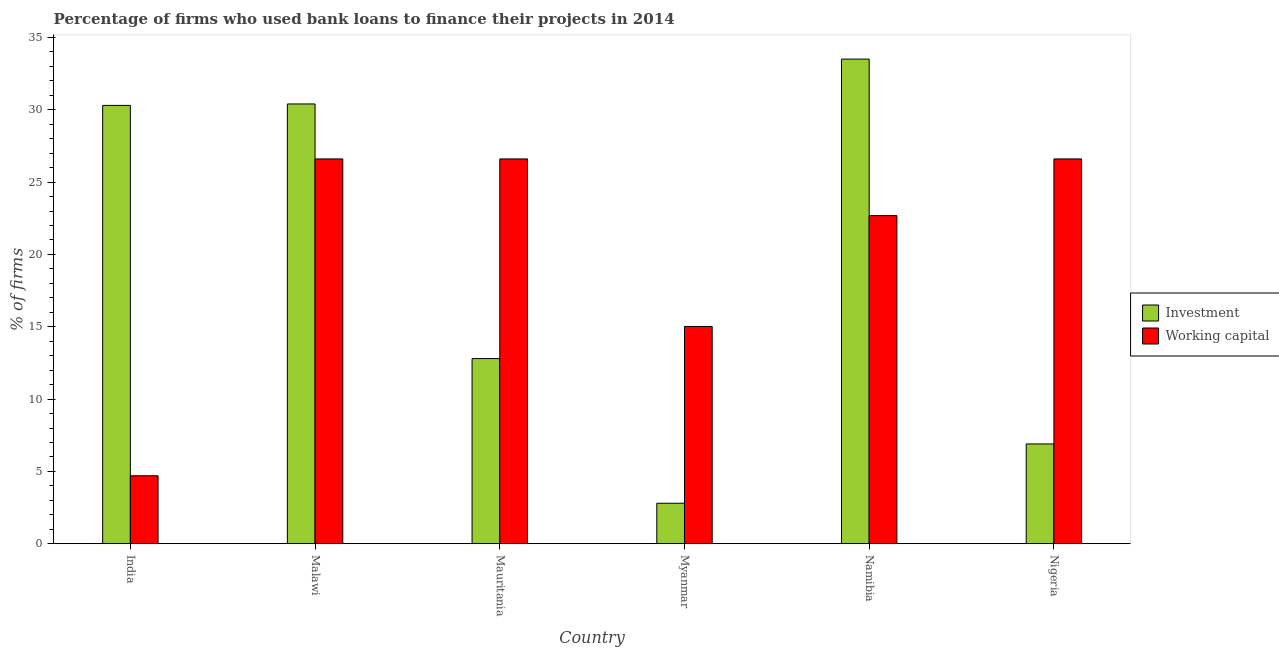How many groups of bars are there?
Give a very brief answer. 6. Are the number of bars on each tick of the X-axis equal?
Your response must be concise. Yes. How many bars are there on the 4th tick from the right?
Provide a succinct answer. 2. What is the label of the 3rd group of bars from the left?
Offer a very short reply. Mauritania. What is the percentage of firms using banks to finance working capital in Malawi?
Give a very brief answer. 26.6. Across all countries, what is the maximum percentage of firms using banks to finance investment?
Provide a succinct answer. 33.5. In which country was the percentage of firms using banks to finance investment maximum?
Ensure brevity in your answer.  Namibia. In which country was the percentage of firms using banks to finance working capital minimum?
Provide a succinct answer. India. What is the total percentage of firms using banks to finance working capital in the graph?
Ensure brevity in your answer.  122.2. What is the difference between the percentage of firms using banks to finance working capital in Myanmar and that in Nigeria?
Ensure brevity in your answer.  -11.58. What is the difference between the percentage of firms using banks to finance investment in Mauritania and the percentage of firms using banks to finance working capital in Namibia?
Provide a succinct answer. -9.88. What is the average percentage of firms using banks to finance working capital per country?
Your answer should be very brief. 20.37. What is the difference between the percentage of firms using banks to finance investment and percentage of firms using banks to finance working capital in Nigeria?
Offer a terse response. -19.7. What is the ratio of the percentage of firms using banks to finance working capital in Malawi to that in Myanmar?
Your answer should be compact. 1.77. What is the difference between the highest and the second highest percentage of firms using banks to finance investment?
Ensure brevity in your answer.  3.1. What is the difference between the highest and the lowest percentage of firms using banks to finance investment?
Offer a very short reply. 30.7. What does the 1st bar from the left in Malawi represents?
Your answer should be compact. Investment. What does the 2nd bar from the right in Namibia represents?
Give a very brief answer. Investment. Are all the bars in the graph horizontal?
Keep it short and to the point. No. What is the difference between two consecutive major ticks on the Y-axis?
Make the answer very short. 5. Does the graph contain any zero values?
Make the answer very short. No. Where does the legend appear in the graph?
Give a very brief answer. Center right. How many legend labels are there?
Provide a short and direct response. 2. How are the legend labels stacked?
Provide a short and direct response. Vertical. What is the title of the graph?
Give a very brief answer. Percentage of firms who used bank loans to finance their projects in 2014. Does "IMF concessional" appear as one of the legend labels in the graph?
Offer a very short reply. No. What is the label or title of the X-axis?
Give a very brief answer. Country. What is the label or title of the Y-axis?
Offer a terse response. % of firms. What is the % of firms in Investment in India?
Offer a very short reply. 30.3. What is the % of firms in Investment in Malawi?
Ensure brevity in your answer.  30.4. What is the % of firms in Working capital in Malawi?
Your answer should be very brief. 26.6. What is the % of firms in Working capital in Mauritania?
Provide a succinct answer. 26.6. What is the % of firms of Investment in Myanmar?
Ensure brevity in your answer.  2.8. What is the % of firms of Working capital in Myanmar?
Offer a terse response. 15.02. What is the % of firms in Investment in Namibia?
Keep it short and to the point. 33.5. What is the % of firms of Working capital in Namibia?
Offer a very short reply. 22.68. What is the % of firms of Investment in Nigeria?
Provide a short and direct response. 6.9. What is the % of firms in Working capital in Nigeria?
Your answer should be compact. 26.6. Across all countries, what is the maximum % of firms of Investment?
Ensure brevity in your answer.  33.5. Across all countries, what is the maximum % of firms of Working capital?
Ensure brevity in your answer.  26.6. Across all countries, what is the minimum % of firms of Working capital?
Your response must be concise. 4.7. What is the total % of firms of Investment in the graph?
Provide a short and direct response. 116.7. What is the total % of firms in Working capital in the graph?
Your answer should be compact. 122.2. What is the difference between the % of firms in Working capital in India and that in Malawi?
Provide a succinct answer. -21.9. What is the difference between the % of firms in Investment in India and that in Mauritania?
Your answer should be compact. 17.5. What is the difference between the % of firms in Working capital in India and that in Mauritania?
Keep it short and to the point. -21.9. What is the difference between the % of firms in Investment in India and that in Myanmar?
Give a very brief answer. 27.5. What is the difference between the % of firms in Working capital in India and that in Myanmar?
Your response must be concise. -10.32. What is the difference between the % of firms in Investment in India and that in Namibia?
Your response must be concise. -3.2. What is the difference between the % of firms in Working capital in India and that in Namibia?
Ensure brevity in your answer.  -17.98. What is the difference between the % of firms in Investment in India and that in Nigeria?
Make the answer very short. 23.4. What is the difference between the % of firms of Working capital in India and that in Nigeria?
Your answer should be very brief. -21.9. What is the difference between the % of firms of Investment in Malawi and that in Myanmar?
Keep it short and to the point. 27.6. What is the difference between the % of firms in Working capital in Malawi and that in Myanmar?
Provide a short and direct response. 11.58. What is the difference between the % of firms of Investment in Malawi and that in Namibia?
Keep it short and to the point. -3.1. What is the difference between the % of firms in Working capital in Malawi and that in Namibia?
Your response must be concise. 3.92. What is the difference between the % of firms of Investment in Malawi and that in Nigeria?
Ensure brevity in your answer.  23.5. What is the difference between the % of firms in Working capital in Mauritania and that in Myanmar?
Keep it short and to the point. 11.58. What is the difference between the % of firms in Investment in Mauritania and that in Namibia?
Give a very brief answer. -20.7. What is the difference between the % of firms in Working capital in Mauritania and that in Namibia?
Keep it short and to the point. 3.92. What is the difference between the % of firms in Investment in Myanmar and that in Namibia?
Provide a short and direct response. -30.7. What is the difference between the % of firms of Working capital in Myanmar and that in Namibia?
Your response must be concise. -7.66. What is the difference between the % of firms in Investment in Myanmar and that in Nigeria?
Your answer should be compact. -4.1. What is the difference between the % of firms of Working capital in Myanmar and that in Nigeria?
Ensure brevity in your answer.  -11.58. What is the difference between the % of firms in Investment in Namibia and that in Nigeria?
Ensure brevity in your answer.  26.6. What is the difference between the % of firms in Working capital in Namibia and that in Nigeria?
Give a very brief answer. -3.92. What is the difference between the % of firms of Investment in India and the % of firms of Working capital in Malawi?
Keep it short and to the point. 3.7. What is the difference between the % of firms of Investment in India and the % of firms of Working capital in Mauritania?
Provide a succinct answer. 3.7. What is the difference between the % of firms of Investment in India and the % of firms of Working capital in Myanmar?
Your answer should be compact. 15.28. What is the difference between the % of firms in Investment in India and the % of firms in Working capital in Namibia?
Offer a very short reply. 7.62. What is the difference between the % of firms in Investment in India and the % of firms in Working capital in Nigeria?
Make the answer very short. 3.7. What is the difference between the % of firms of Investment in Malawi and the % of firms of Working capital in Myanmar?
Your answer should be compact. 15.38. What is the difference between the % of firms in Investment in Malawi and the % of firms in Working capital in Namibia?
Provide a short and direct response. 7.72. What is the difference between the % of firms of Investment in Mauritania and the % of firms of Working capital in Myanmar?
Make the answer very short. -2.22. What is the difference between the % of firms in Investment in Mauritania and the % of firms in Working capital in Namibia?
Provide a short and direct response. -9.88. What is the difference between the % of firms of Investment in Mauritania and the % of firms of Working capital in Nigeria?
Your response must be concise. -13.8. What is the difference between the % of firms in Investment in Myanmar and the % of firms in Working capital in Namibia?
Give a very brief answer. -19.88. What is the difference between the % of firms in Investment in Myanmar and the % of firms in Working capital in Nigeria?
Keep it short and to the point. -23.8. What is the average % of firms of Investment per country?
Offer a terse response. 19.45. What is the average % of firms in Working capital per country?
Keep it short and to the point. 20.37. What is the difference between the % of firms of Investment and % of firms of Working capital in India?
Provide a short and direct response. 25.6. What is the difference between the % of firms in Investment and % of firms in Working capital in Malawi?
Provide a succinct answer. 3.8. What is the difference between the % of firms in Investment and % of firms in Working capital in Mauritania?
Make the answer very short. -13.8. What is the difference between the % of firms of Investment and % of firms of Working capital in Myanmar?
Provide a short and direct response. -12.22. What is the difference between the % of firms of Investment and % of firms of Working capital in Namibia?
Offer a terse response. 10.82. What is the difference between the % of firms of Investment and % of firms of Working capital in Nigeria?
Provide a succinct answer. -19.7. What is the ratio of the % of firms in Working capital in India to that in Malawi?
Keep it short and to the point. 0.18. What is the ratio of the % of firms of Investment in India to that in Mauritania?
Offer a terse response. 2.37. What is the ratio of the % of firms of Working capital in India to that in Mauritania?
Provide a short and direct response. 0.18. What is the ratio of the % of firms in Investment in India to that in Myanmar?
Your response must be concise. 10.82. What is the ratio of the % of firms in Working capital in India to that in Myanmar?
Offer a terse response. 0.31. What is the ratio of the % of firms of Investment in India to that in Namibia?
Keep it short and to the point. 0.9. What is the ratio of the % of firms in Working capital in India to that in Namibia?
Your response must be concise. 0.21. What is the ratio of the % of firms of Investment in India to that in Nigeria?
Offer a very short reply. 4.39. What is the ratio of the % of firms of Working capital in India to that in Nigeria?
Keep it short and to the point. 0.18. What is the ratio of the % of firms of Investment in Malawi to that in Mauritania?
Provide a short and direct response. 2.38. What is the ratio of the % of firms in Working capital in Malawi to that in Mauritania?
Provide a short and direct response. 1. What is the ratio of the % of firms of Investment in Malawi to that in Myanmar?
Your response must be concise. 10.86. What is the ratio of the % of firms in Working capital in Malawi to that in Myanmar?
Your answer should be very brief. 1.77. What is the ratio of the % of firms in Investment in Malawi to that in Namibia?
Keep it short and to the point. 0.91. What is the ratio of the % of firms of Working capital in Malawi to that in Namibia?
Your answer should be compact. 1.17. What is the ratio of the % of firms in Investment in Malawi to that in Nigeria?
Your answer should be very brief. 4.41. What is the ratio of the % of firms of Working capital in Malawi to that in Nigeria?
Offer a terse response. 1. What is the ratio of the % of firms of Investment in Mauritania to that in Myanmar?
Provide a succinct answer. 4.57. What is the ratio of the % of firms of Working capital in Mauritania to that in Myanmar?
Your answer should be very brief. 1.77. What is the ratio of the % of firms in Investment in Mauritania to that in Namibia?
Your answer should be very brief. 0.38. What is the ratio of the % of firms in Working capital in Mauritania to that in Namibia?
Give a very brief answer. 1.17. What is the ratio of the % of firms of Investment in Mauritania to that in Nigeria?
Your response must be concise. 1.86. What is the ratio of the % of firms of Working capital in Mauritania to that in Nigeria?
Keep it short and to the point. 1. What is the ratio of the % of firms in Investment in Myanmar to that in Namibia?
Your answer should be compact. 0.08. What is the ratio of the % of firms of Working capital in Myanmar to that in Namibia?
Give a very brief answer. 0.66. What is the ratio of the % of firms of Investment in Myanmar to that in Nigeria?
Offer a very short reply. 0.41. What is the ratio of the % of firms in Working capital in Myanmar to that in Nigeria?
Keep it short and to the point. 0.56. What is the ratio of the % of firms in Investment in Namibia to that in Nigeria?
Make the answer very short. 4.86. What is the ratio of the % of firms of Working capital in Namibia to that in Nigeria?
Offer a very short reply. 0.85. What is the difference between the highest and the second highest % of firms in Investment?
Your answer should be compact. 3.1. What is the difference between the highest and the second highest % of firms in Working capital?
Your response must be concise. 0. What is the difference between the highest and the lowest % of firms of Investment?
Offer a terse response. 30.7. What is the difference between the highest and the lowest % of firms of Working capital?
Offer a terse response. 21.9. 